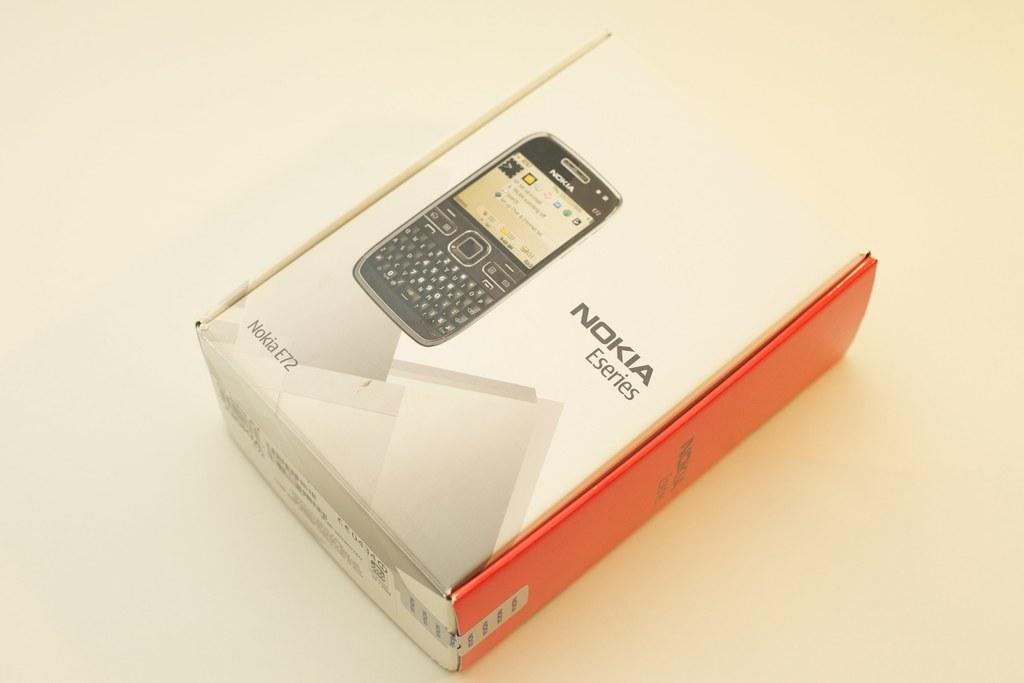<image>
Write a terse but informative summary of the picture. A box for a Nokia E72 is displayed on a white background. 